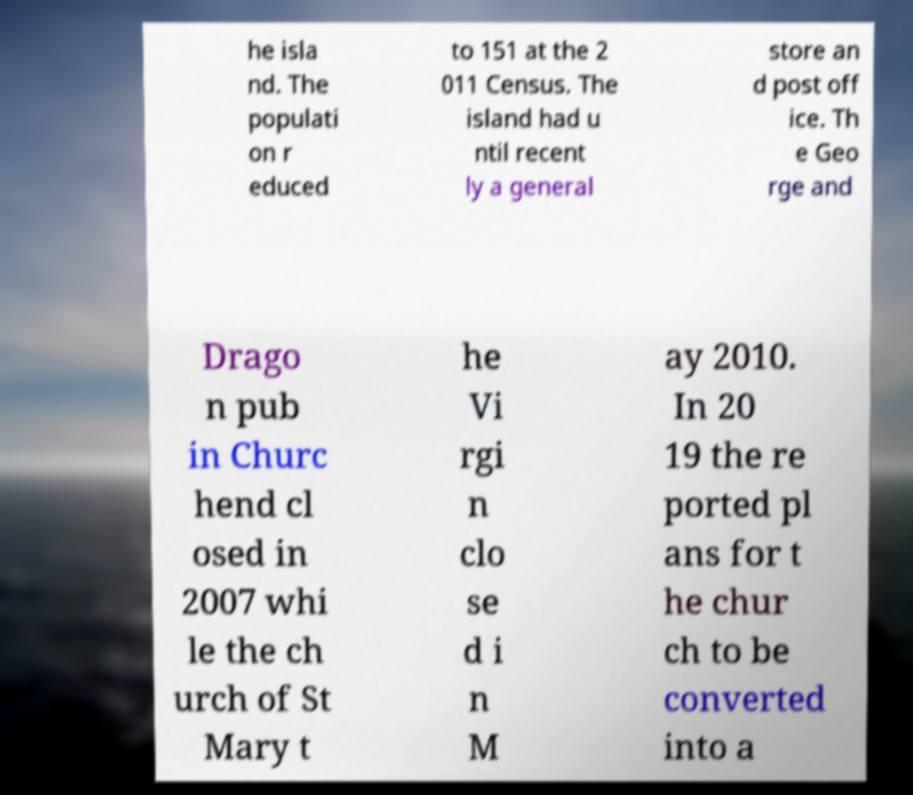Can you accurately transcribe the text from the provided image for me? he isla nd. The populati on r educed to 151 at the 2 011 Census. The island had u ntil recent ly a general store an d post off ice. Th e Geo rge and Drago n pub in Churc hend cl osed in 2007 whi le the ch urch of St Mary t he Vi rgi n clo se d i n M ay 2010. In 20 19 the re ported pl ans for t he chur ch to be converted into a 